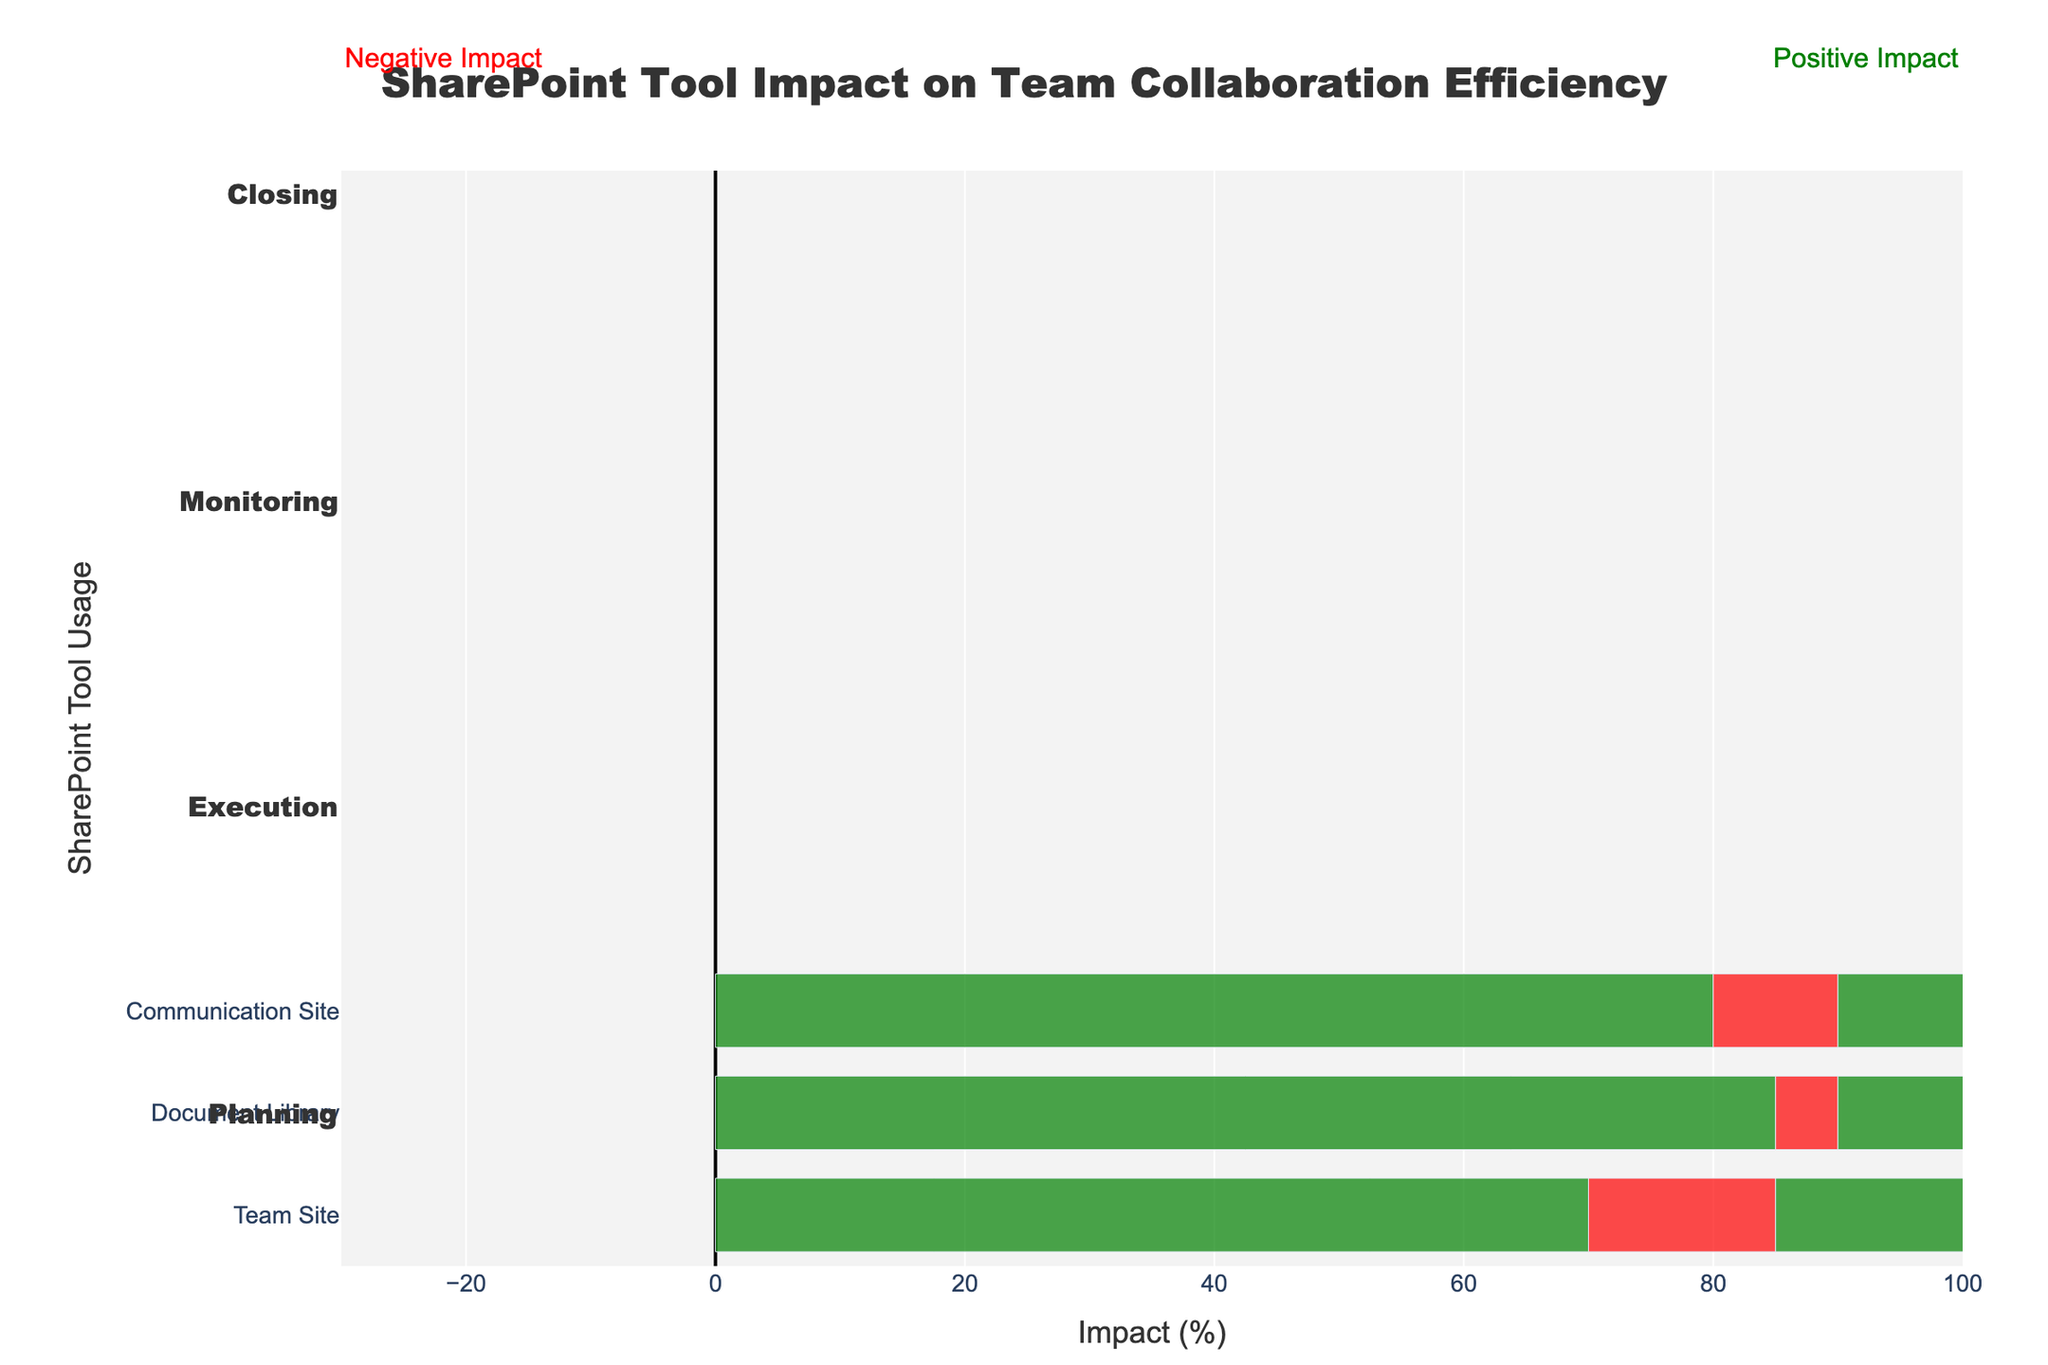What is the SharePoint tool with the highest Positive Impact in the Planning phase? To find the tool with the highest Positive Impact in the Planning phase, look at the green bars for the Planning phase and identify the longest bar. The Document Library has the longest green bar with a Positive Impact of 85.
Answer: Document Library Which phase has the highest Negative Impact for Team Site usage? To identify the phase with the highest Negative Impact for Team Site usage, look at the red bars for Team Site across all phases and compare their lengths. The Execution phase has the highest Negative Impact with a value of 25.
Answer: Execution Comparing Document Library and Communication Site, which has a higher Positive Impact during the Closing phase, and by how much? Look at the green bars for Document Library and Communication Site in the Closing phase. Document Library has a Positive Impact of 80, while Communication Site has 75. The difference is 80 - 75 = 5.
Answer: Document Library by 5 What is the average Positive Impact of all SharePoint tools in the Monitoring phase? Sum the Positive Impacts of Document Library, Communication Site, and Team Site in the Monitoring phase: 78 + 74 + 68 = 220. Divide this by 3 to get the average: 220 / 3 = 73.33.
Answer: 73.33 Which SharePoint tool has the smallest difference between Positive and Negative Impacts in the Execution phase? Calculate the difference between Positive and Negative Impacts for each tool in the Execution phase. Document Library: 75 - 10 = 65, Communication Site: 65 - 20 = 45, Team Site: 55 - 25 = 30. The smallest difference is for Team Site.
Answer: Team Site How much greater is the Positive Impact of Document Library compared to its Negative Impact in the Planning phase? In the Planning phase for Document Library, the Positive Impact is 85 and the Negative Impact is 5. Subtract the Negative from the Positive: 85 - 5 = 80.
Answer: 80 Which SharePoint tool shows a decrease in Positive Impact from the Planning phase to the Execution phase? Identify tools whose green bars are shorter in Execution than in Planning. Document Library decreases from 85 to 75, Communication Site from 80 to 65, and Team Site from 70 to 55. Thus, all tools show a decrease.
Answer: All tools By how much does the Negative Impact of Communication Site increase from Planning to Execution? The Negative Impact for Communication Site is 10 in the Planning phase and 20 in the Execution phase. Subtract the Planning value from the Execution value: 20 - 10 = 10.
Answer: 10 What is the total Positive Impact for Team Site across all phases? Sum the Positive Impacts of Team Site in each phase: Planning 70, Execution 55, Monitoring 68, and Closing 73. The total is 70 + 55 + 68 + 73 = 266.
Answer: 266 In which phase does Document Library have the least Positive Impact? Compare the green bars for Document Library across all phases. The smallest is in the Execution phase with a Positive Impact of 75.
Answer: Execution 